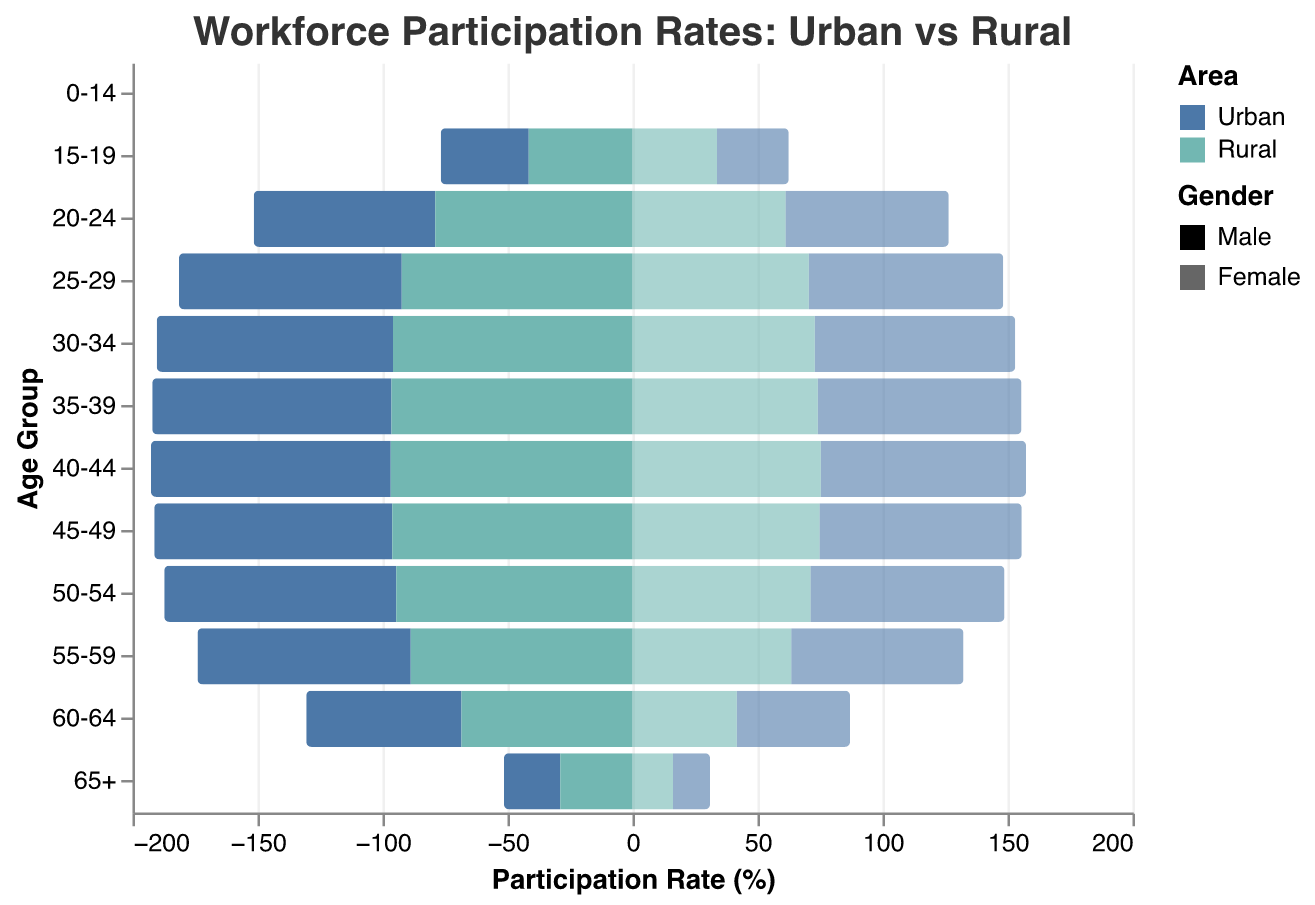What is the title of the figure? The title of the figure is displayed prominently at the top and reads "Workforce Participation Rates: Urban vs Rural".
Answer: Workforce Participation Rates: Urban vs Rural Which age group has the highest workforce participation rate for urban males? By observing the bar lengths within each age group for urban males, the age group 40-44 shows the highest participation rate at 95.9%.
Answer: 40-44 How do the participation rates for rural females compare to urban females in the 55-59 age group? Compare the bar lengths for rural females and urban females within the 55-59 age group. The participation rate for rural females is 63.5%, while for urban females it is 68.9%.
Answer: Urban females have a higher participation rate What is the average workforce participation rate for urban males aged 25-34? Calculate the average of the participation rates for urban males in the age groups 25-29 and 30-34. That is (89.1 + 94.5)/2 = 91.8.
Answer: 91.8 Which gender shows a higher participation rate in rural areas for the age group 30-34? Compare participation rates for rural males and rural females within the 30-34 age group. The rate for rural males is 95.8% and for rural females is 72.9%, so males have a higher rate.
Answer: Males Are workforce participation rates higher in urban or rural areas for the age group 20-24? Compare the rates in urban and rural areas within the 20-24 age group. The rates are 72.6% (urban male), 65.3% (urban female), 78.9% (rural male), and 61.2% (rural female). Rural males have a higher rate than urban males, but urban females have a higher rate than rural females. Overall, rural areas have higher participation.
Answer: Rural By how much do workforce participation rates for urban males decline from the 45-49 age group to the 60-64 age group? Subtract the participation rate of urban males in the 60-64 age group from that in the 45-49 age group. That is 95.2% - 62.1% = 33.1%.
Answer: 33.1% In which age group is the difference between urban males and urban females the smallest? Compare the differences in participation rates for urban males and urban females across all age groups. The smallest difference is 40-44 with a difference of 95.9% - 82.1% = 13.8%.
Answer: 40-44 Which age group has the least participation rate overall, and how is that distributed between urban and rural areas? The age group 65+ has the least participation rate overall. Participation rates are: Urban Male 22.5%, Urban Female 14.8%, Rural Male 28.9%, and Rural Female 16.2%.
Answer: 65+, Urban Male 22.5%, Urban Female 14.8%, Rural Male 28.9%, Rural Female 16.2% 